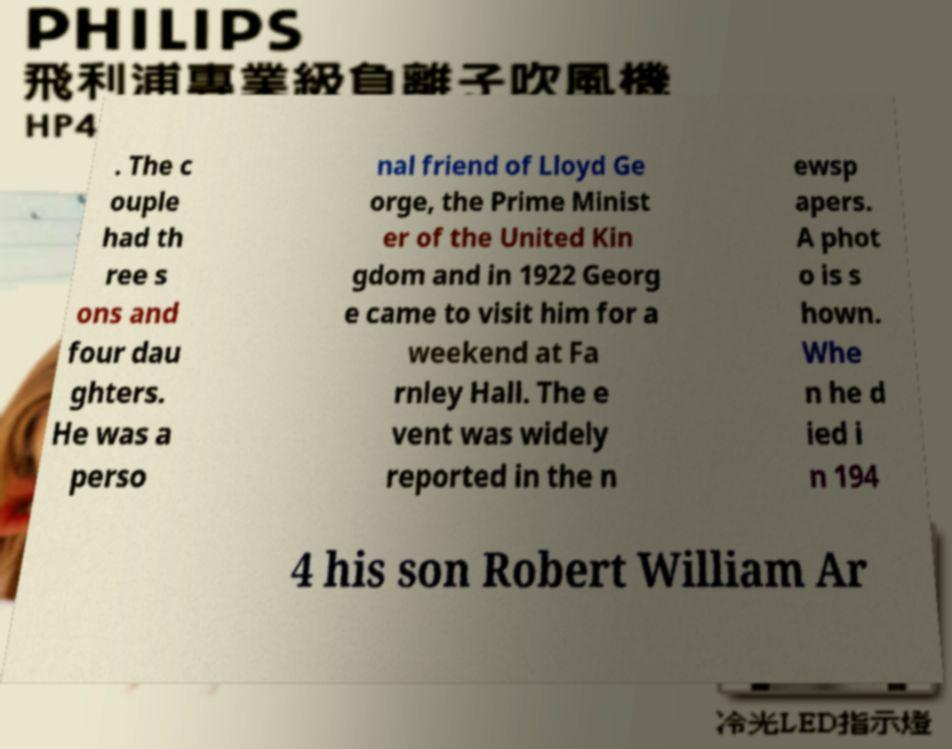What messages or text are displayed in this image? I need them in a readable, typed format. . The c ouple had th ree s ons and four dau ghters. He was a perso nal friend of Lloyd Ge orge, the Prime Minist er of the United Kin gdom and in 1922 Georg e came to visit him for a weekend at Fa rnley Hall. The e vent was widely reported in the n ewsp apers. A phot o is s hown. Whe n he d ied i n 194 4 his son Robert William Ar 